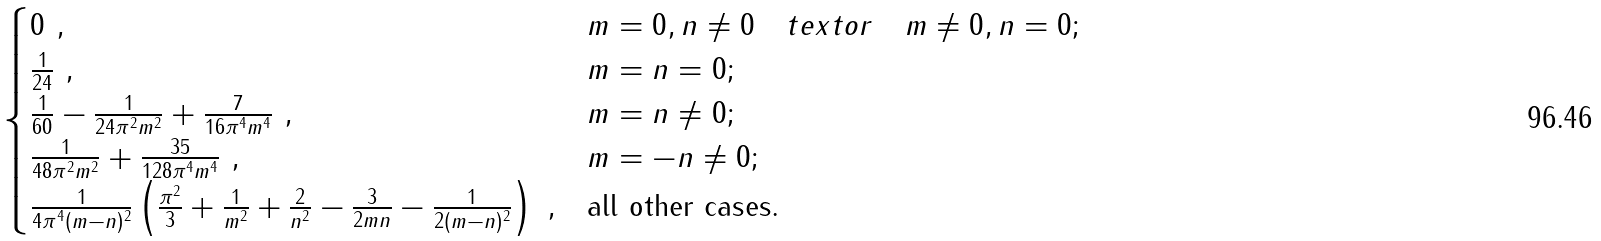Convert formula to latex. <formula><loc_0><loc_0><loc_500><loc_500>\begin{cases} 0 \ , & m = 0 , n \ne 0 \quad t e x t { o r } \quad m \ne 0 , n = 0 ; \\ \frac { 1 } { 2 4 } \ , & m = n = 0 ; \\ \frac { 1 } { 6 0 } - \frac { 1 } { 2 4 \pi ^ { 2 } m ^ { 2 } } + \frac { 7 } { 1 6 \pi ^ { 4 } m ^ { 4 } } \ , & m = n \ne 0 ; \\ \frac { 1 } { 4 8 \pi ^ { 2 } m ^ { 2 } } + \frac { 3 5 } { 1 2 8 \pi ^ { 4 } m ^ { 4 } } \ , & m = - n \ne 0 ; \\ \frac { 1 } { 4 \pi ^ { 4 } ( m - n ) ^ { 2 } } \left ( \frac { \pi ^ { 2 } } { 3 } + \frac { 1 } { m ^ { 2 } } + \frac { 2 } { n ^ { 2 } } - \frac { 3 } { 2 m n } - \frac { 1 } { 2 ( m - n ) ^ { 2 } } \right ) \ , & \text {all other cases.} \end{cases}</formula> 